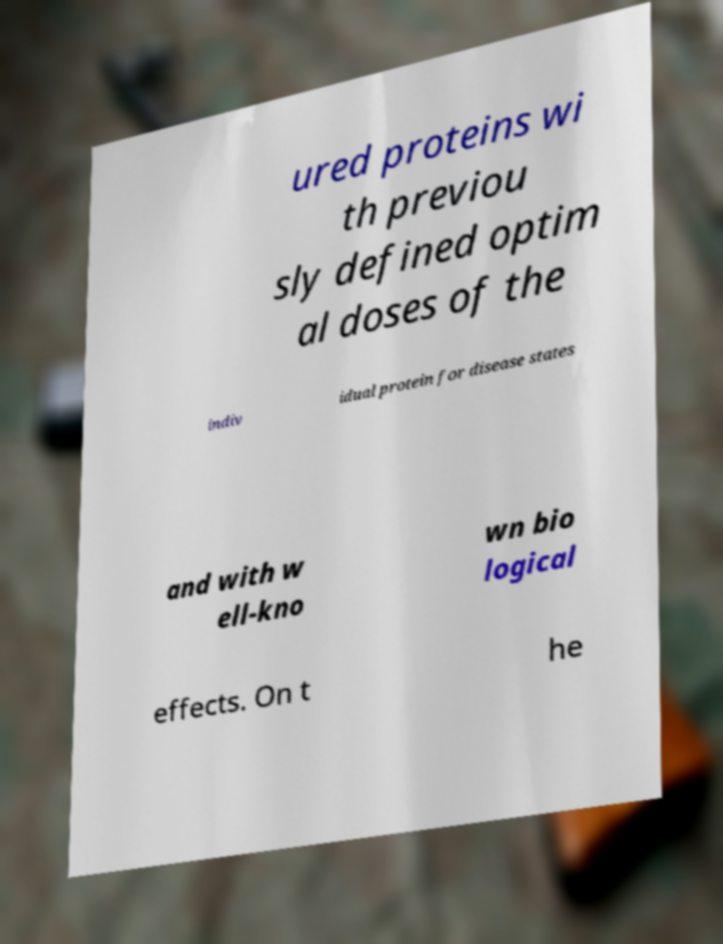Can you read and provide the text displayed in the image?This photo seems to have some interesting text. Can you extract and type it out for me? ured proteins wi th previou sly defined optim al doses of the indiv idual protein for disease states and with w ell-kno wn bio logical effects. On t he 